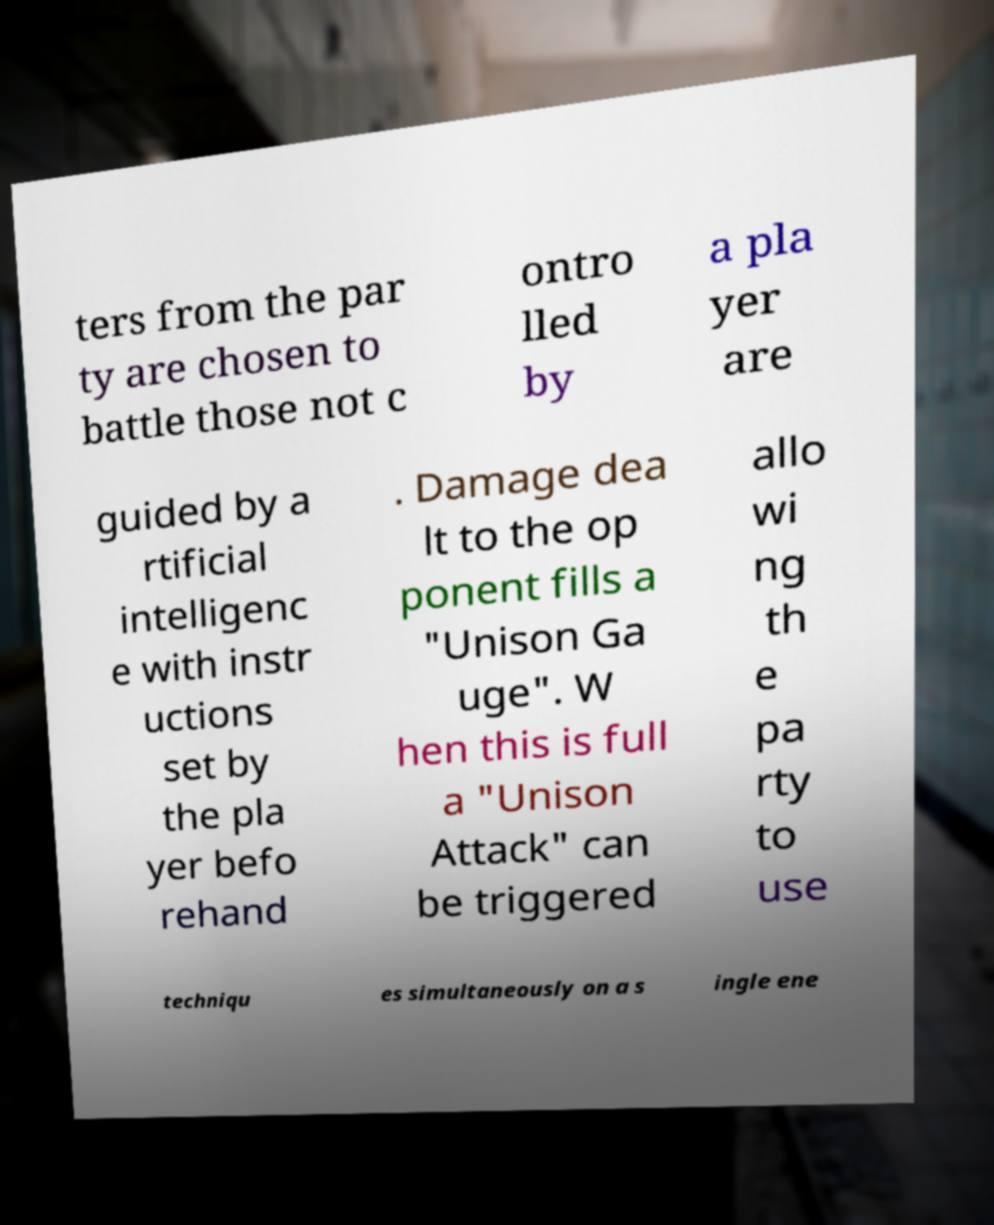Can you accurately transcribe the text from the provided image for me? ters from the par ty are chosen to battle those not c ontro lled by a pla yer are guided by a rtificial intelligenc e with instr uctions set by the pla yer befo rehand . Damage dea lt to the op ponent fills a "Unison Ga uge". W hen this is full a "Unison Attack" can be triggered allo wi ng th e pa rty to use techniqu es simultaneously on a s ingle ene 